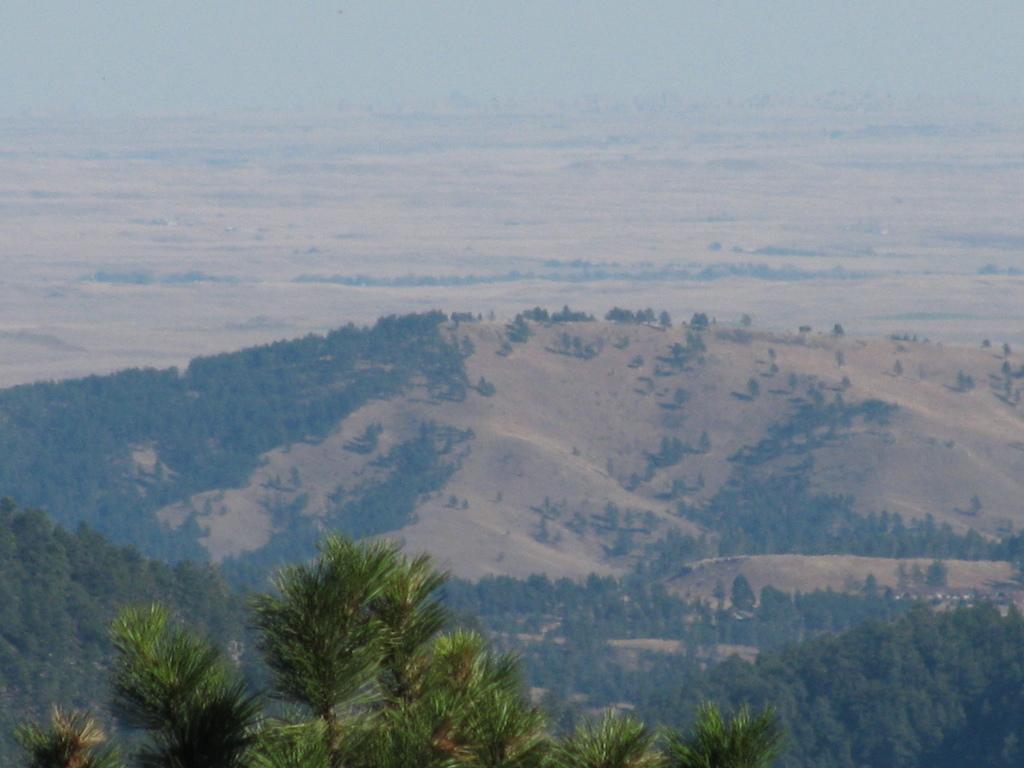In one or two sentences, can you explain what this image depicts? In this image I can see few trees which are green in color. In the background I can see few mountains, few trees on the mountains and the sky. 